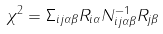<formula> <loc_0><loc_0><loc_500><loc_500>\chi ^ { 2 } = \Sigma _ { i j \alpha \beta } R _ { i \alpha } N _ { i j \alpha \beta } ^ { - 1 } R _ { j \beta }</formula> 